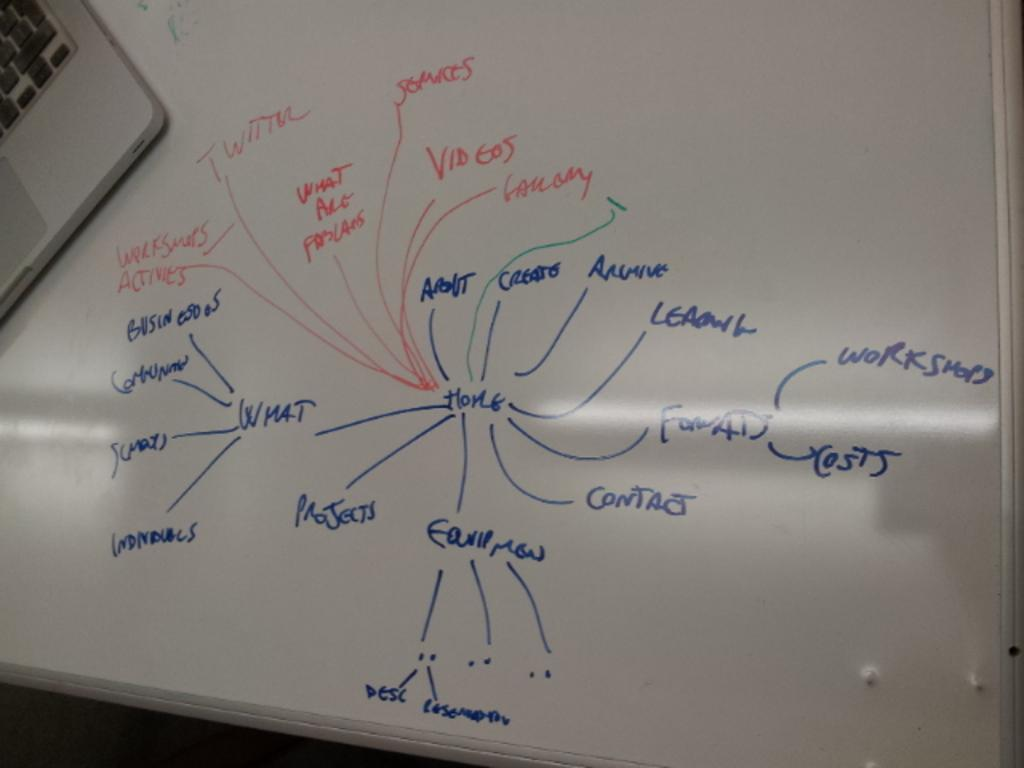<image>
Offer a succinct explanation of the picture presented. A white board with a diagram with Home in the middle has a laptop sitting next to it. 